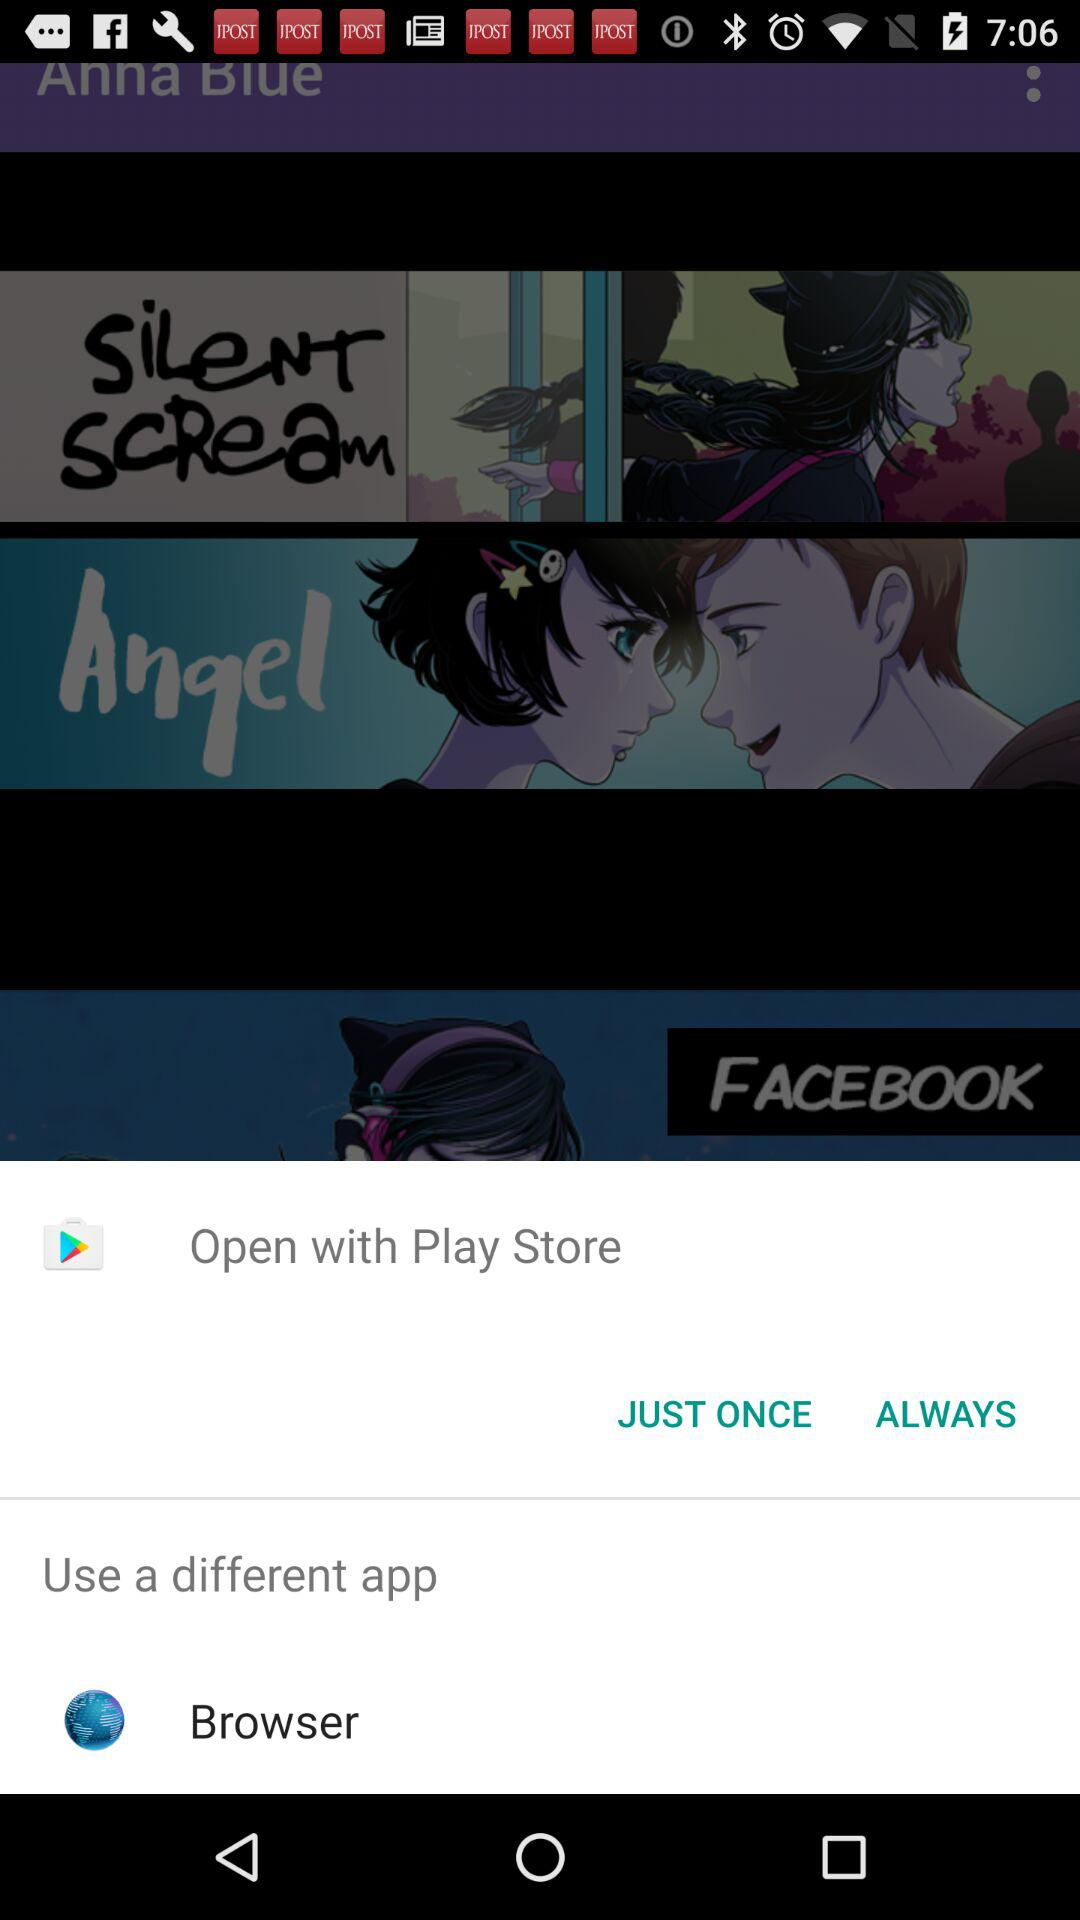Which app is used to open the content?
When the provided information is insufficient, respond with <no answer>. <no answer> 